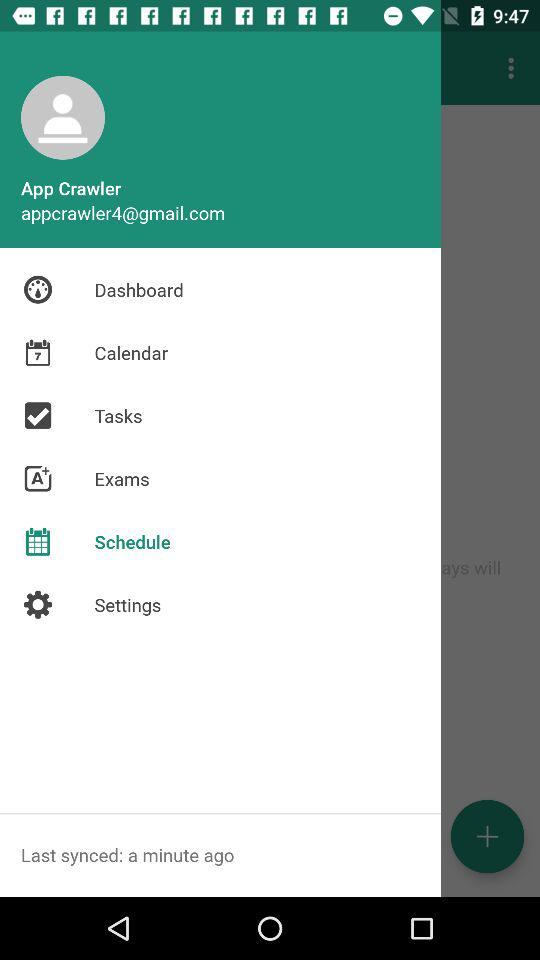What is the name of the user? The name of the user is App Crawler. 